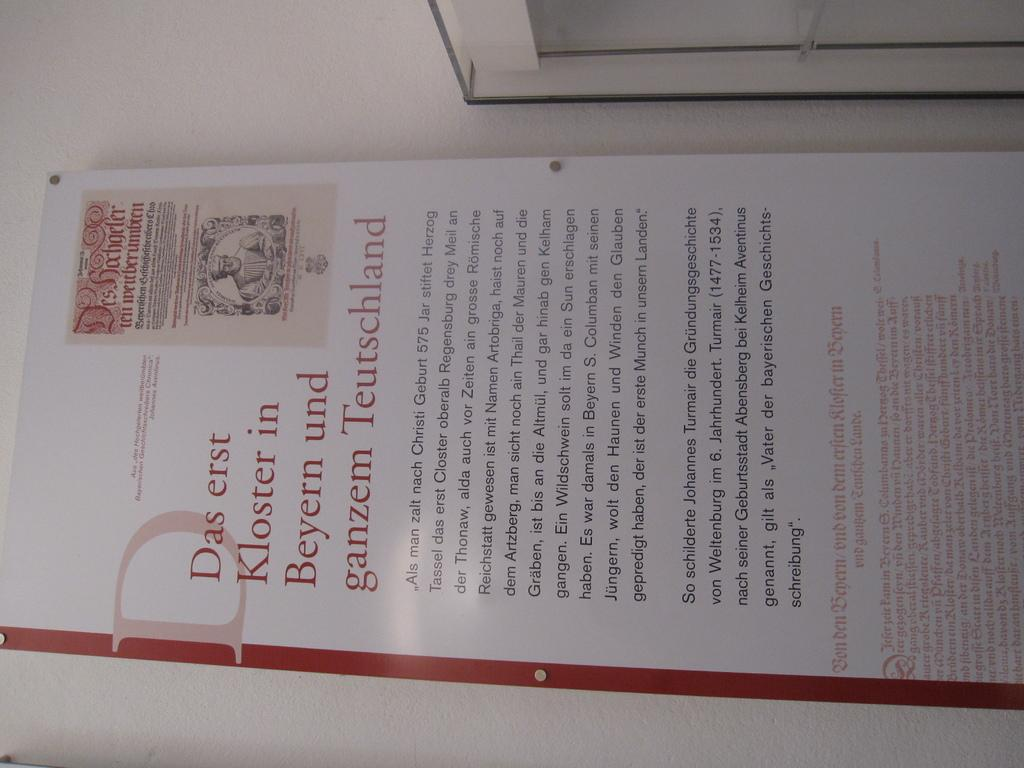<image>
Render a clear and concise summary of the photo. The start of this document is worded Das erst. 